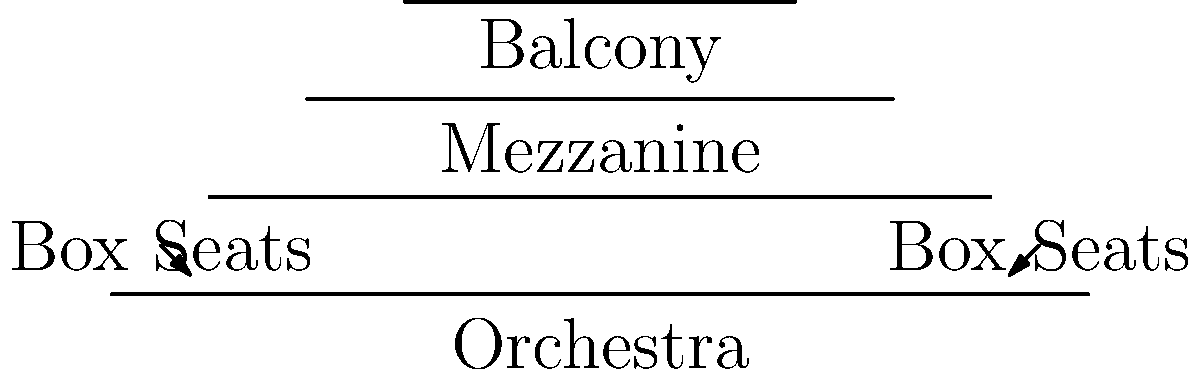As a Broadway producer, you're designing a new theater layout to maximize audience engagement and critic approval. The theater has four distinct seating areas: Orchestra, Mezzanine, Balcony, and Box Seats. If the total seating capacity is 1200, and you want to allocate seats in the ratio of 5:3:2:1 for Orchestra, Mezzanine, Balcony, and Box Seats respectively, how many seats should be in the Mezzanine section? To solve this problem, let's follow these steps:

1. Understand the ratio: 
   Orchestra : Mezzanine : Balcony : Box Seats = 5 : 3 : 2 : 1

2. Calculate the total parts in the ratio:
   $5 + 3 + 2 + 1 = 11$ parts

3. Calculate the number of seats per part:
   Total seats ÷ Total parts = $1200 \div 11 = 109.09$ seats per part

4. Calculate the number of seats for each section:
   - Orchestra: $5 \times 109.09 = 545.45$ seats
   - Mezzanine: $3 \times 109.09 = 327.27$ seats
   - Balcony: $2 \times 109.09 = 218.18$ seats
   - Box Seats: $1 \times 109.09 = 109.09$ seats

5. Round the numbers to the nearest whole seat:
   - Orchestra: 545 seats
   - Mezzanine: 327 seats
   - Balcony: 218 seats
   - Box Seats: 110 seats

Therefore, the Mezzanine section should have 327 seats.
Answer: 327 seats 